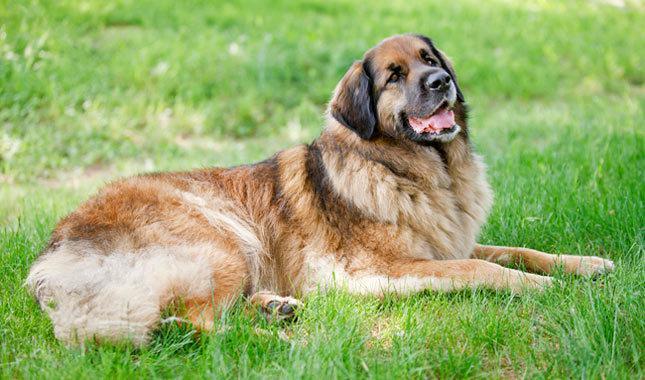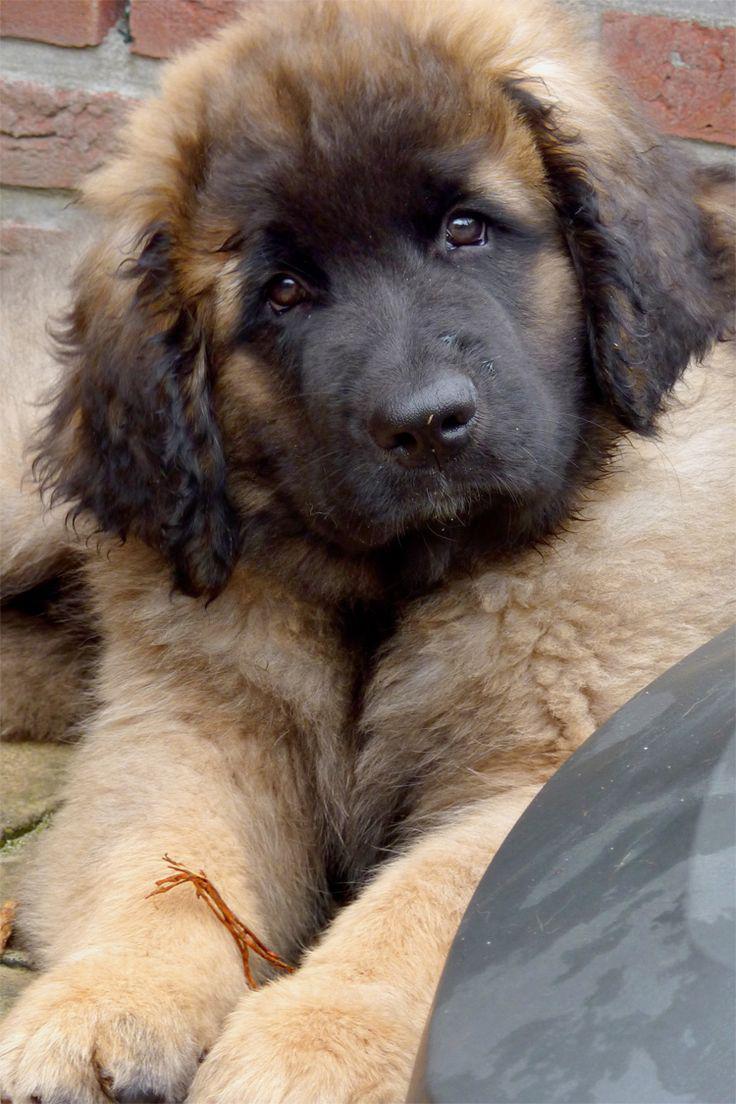The first image is the image on the left, the second image is the image on the right. For the images shown, is this caption "The dog's legs are not visible in any of the images." true? Answer yes or no. No. 